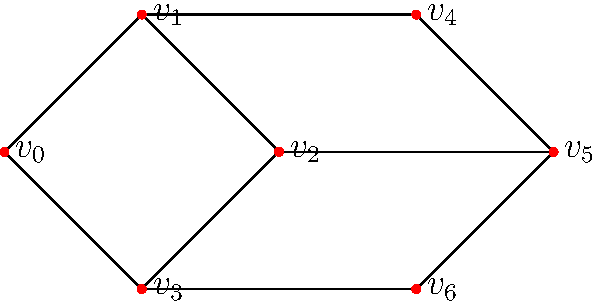As a rising stand-up comedian, you're analyzing the connectivity of comedy clubs in your city. The graph represents comedy clubs as nodes and direct transportation routes between them as edges. What is the minimum number of edges that need to be removed to disconnect the graph into two or more components? To solve this problem, we need to find the minimum cut set of the graph. Here's a step-by-step approach:

1. Observe the graph structure:
   - There are 7 vertices (v₀ to v₆) representing comedy clubs.
   - The edges represent direct transportation routes between clubs.

2. Identify potential cut sets:
   - Removing the edge v₂--v₅ doesn't disconnect the graph.
   - Removing any single edge from the outer loop doesn't disconnect the graph.
   - Removing any single edge from the inner loop doesn't disconnect the graph.

3. Look for the minimum number of edges that, when removed, will disconnect the graph:
   - Removing the edges v₁--v₄ and v₃--v₆ will disconnect the graph into two components.
   - This is the minimum number of edges needed, as removing any single edge doesn't disconnect the graph.

4. Verify the solution:
   - After removing v₁--v₄ and v₃--v₆, we have two separate components:
     Component 1: {v₀, v₁, v₂, v₃}
     Component 2: {v₄, v₅, v₆}
   - No other combination of fewer edges achieves this disconnection.

Therefore, the minimum number of edges that need to be removed to disconnect the graph is 2.
Answer: 2 